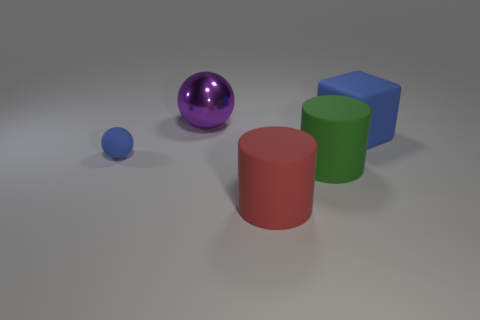Is there any other thing that has the same size as the matte ball?
Your answer should be very brief. No. The thing that is the same color as the big rubber block is what shape?
Provide a succinct answer. Sphere. There is a rubber thing that is right of the large green cylinder; is it the same shape as the large red thing?
Give a very brief answer. No. Is the number of large purple shiny balls in front of the big matte cube greater than the number of purple shiny balls?
Provide a short and direct response. No. How many cubes have the same size as the purple ball?
Offer a very short reply. 1. What size is the ball that is the same color as the block?
Make the answer very short. Small. What number of things are metal spheres or rubber things to the right of the big purple thing?
Offer a very short reply. 4. What color is the big thing that is on the right side of the metallic object and behind the tiny blue sphere?
Your answer should be compact. Blue. Is the green thing the same size as the red cylinder?
Offer a very short reply. Yes. There is a matte cylinder on the right side of the red object; what color is it?
Provide a succinct answer. Green. 